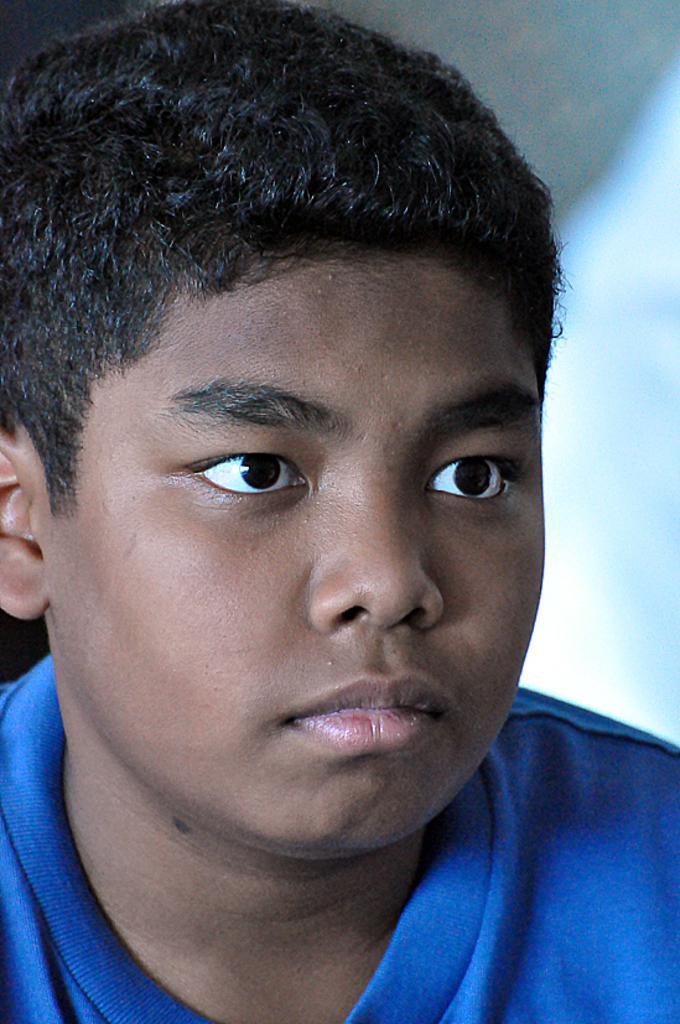Could you give a brief overview of what you see in this image? In the foreground of this picture we can see a person wearing blue color dress. The background of the image is white in color. 